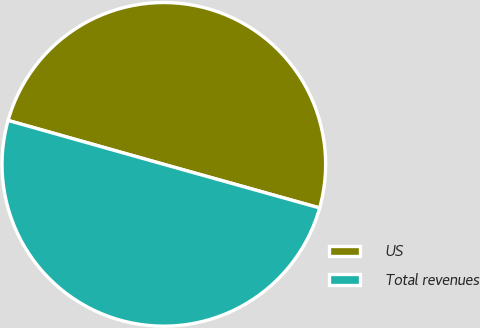<chart> <loc_0><loc_0><loc_500><loc_500><pie_chart><fcel>US<fcel>Total revenues<nl><fcel>49.97%<fcel>50.03%<nl></chart> 